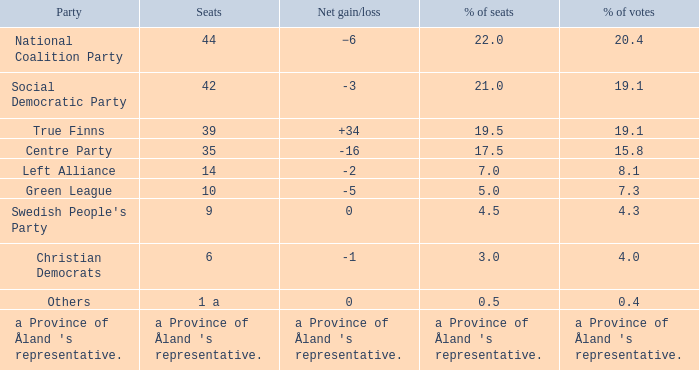Concerning the seats that garnered 14.0. 